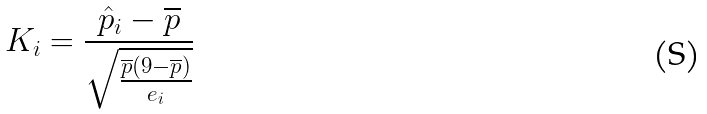Convert formula to latex. <formula><loc_0><loc_0><loc_500><loc_500>K _ { i } = \frac { \hat { p } _ { i } - \overline { p } } { \sqrt { \frac { \overline { p } ( 9 - \overline { p } ) } { e _ { i } } } }</formula> 